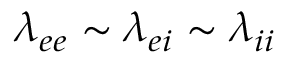<formula> <loc_0><loc_0><loc_500><loc_500>\lambda _ { e e } \sim \lambda _ { e i } \sim \lambda _ { i i }</formula> 